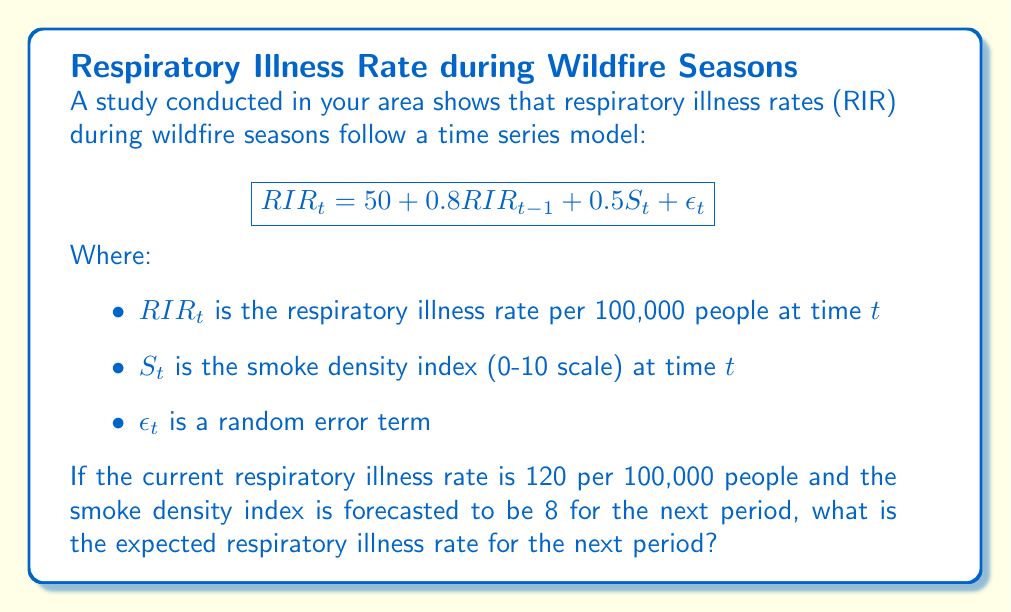Can you answer this question? Let's approach this step-by-step:

1) We are given the time series model:
   $$RIR_t = 50 + 0.8RIR_{t-1} + 0.5S_t + \epsilon_t$$

2) We need to find $RIR_t$ (the expected respiratory illness rate for the next period).

3) We know:
   - $RIR_{t-1} = 120$ (current respiratory illness rate)
   - $S_t = 8$ (forecasted smoke density index for next period)

4) We can ignore $\epsilon_t$ for the expected value calculation as it's a random error term with an expected value of 0.

5) Let's substitute these values into our equation:
   $$RIR_t = 50 + 0.8(120) + 0.5(8) + 0$$

6) Now let's calculate:
   $$RIR_t = 50 + 96 + 4$$
   $$RIR_t = 150$$

Therefore, the expected respiratory illness rate for the next period is 150 per 100,000 people.
Answer: 150 per 100,000 people 